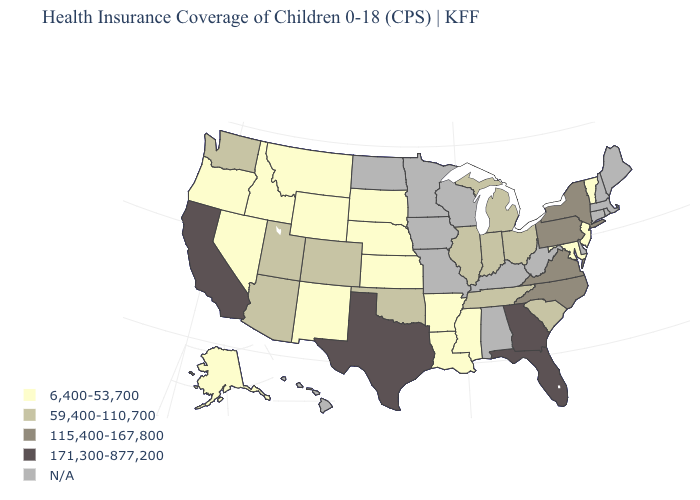Name the states that have a value in the range 115,400-167,800?
Be succinct. New York, North Carolina, Pennsylvania, Virginia. What is the value of Alabama?
Keep it brief. N/A. Is the legend a continuous bar?
Short answer required. No. Does the first symbol in the legend represent the smallest category?
Give a very brief answer. Yes. What is the value of North Carolina?
Quick response, please. 115,400-167,800. What is the highest value in the USA?
Be succinct. 171,300-877,200. What is the highest value in states that border Colorado?
Give a very brief answer. 59,400-110,700. What is the lowest value in the USA?
Answer briefly. 6,400-53,700. What is the lowest value in the USA?
Answer briefly. 6,400-53,700. Does Nebraska have the lowest value in the MidWest?
Give a very brief answer. Yes. Which states hav the highest value in the Northeast?
Concise answer only. New York, Pennsylvania. How many symbols are there in the legend?
Be succinct. 5. How many symbols are there in the legend?
Write a very short answer. 5. 